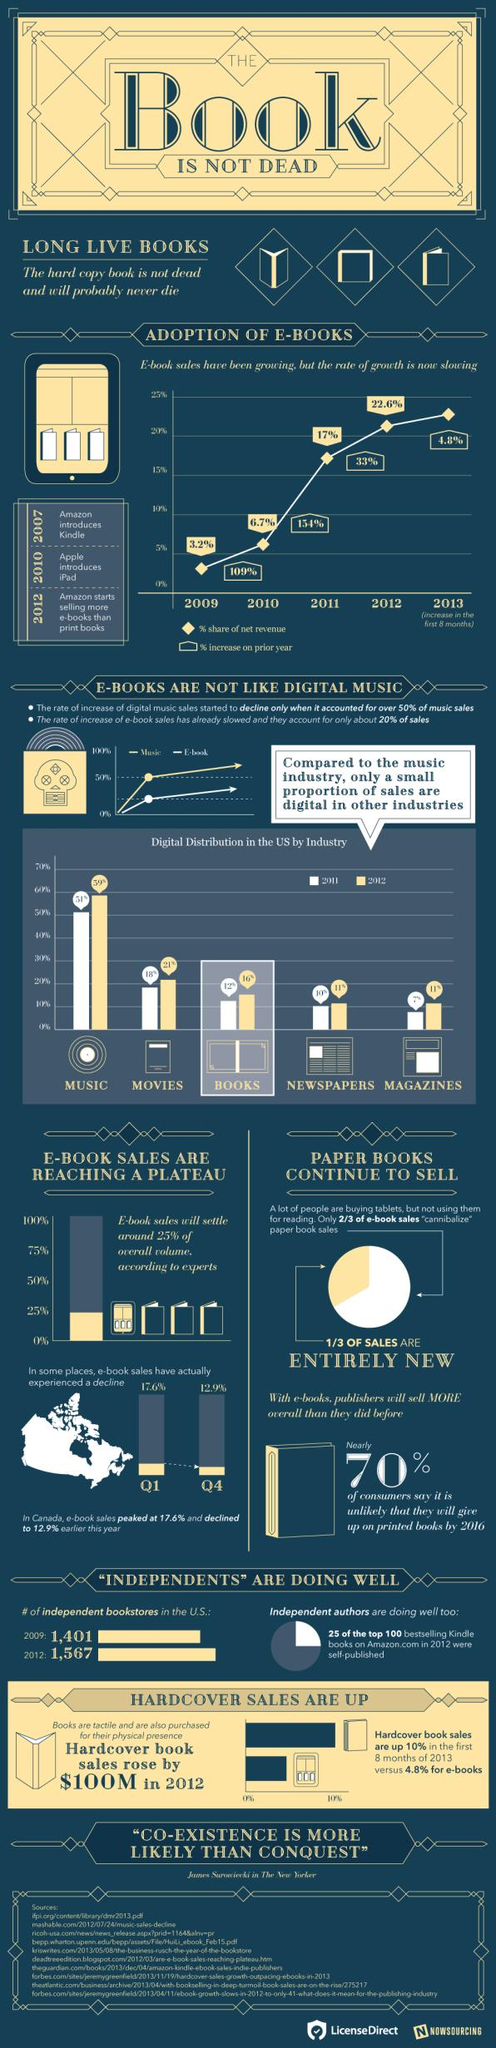Outline some significant characteristics in this image. Amazon began selling more electronic books than physical books in 2012. In 2011, the net revenue from e-book sales accounted for 17% of the total revenue. In 2011, the magazine industry in the United States had the lowest percentage of digital distribution compared to other industries. In 2012, the digital distribution of newspapers in the United States accounted for 11% of overall sales. In 2009, the percentage share of net revenue from e-book sales was 3.2%. 